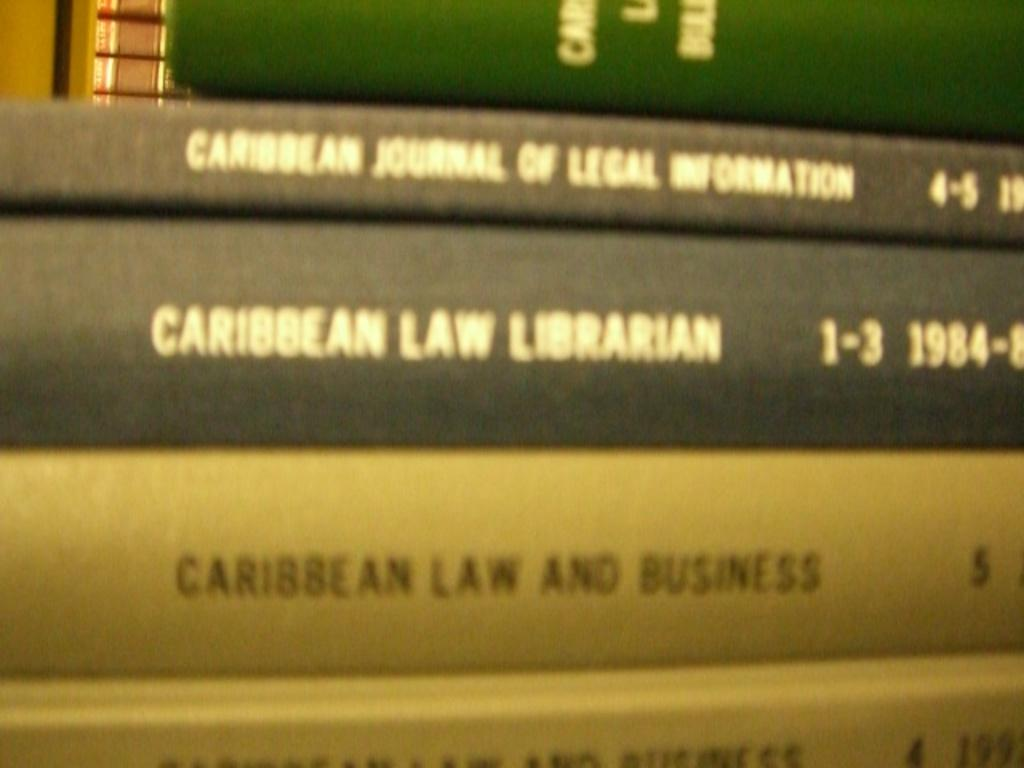Provide a one-sentence caption for the provided image. The books here are titled Caribbean Law and Business. 